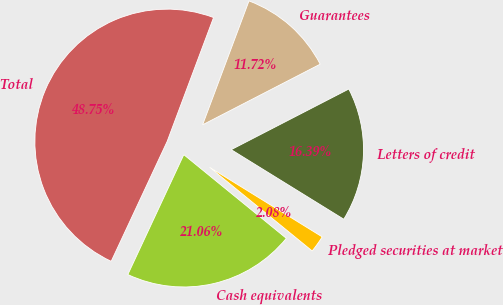Convert chart. <chart><loc_0><loc_0><loc_500><loc_500><pie_chart><fcel>Cash equivalents<fcel>Pledged securities at market<fcel>Letters of credit<fcel>Guarantees<fcel>Total<nl><fcel>21.06%<fcel>2.08%<fcel>16.39%<fcel>11.72%<fcel>48.75%<nl></chart> 